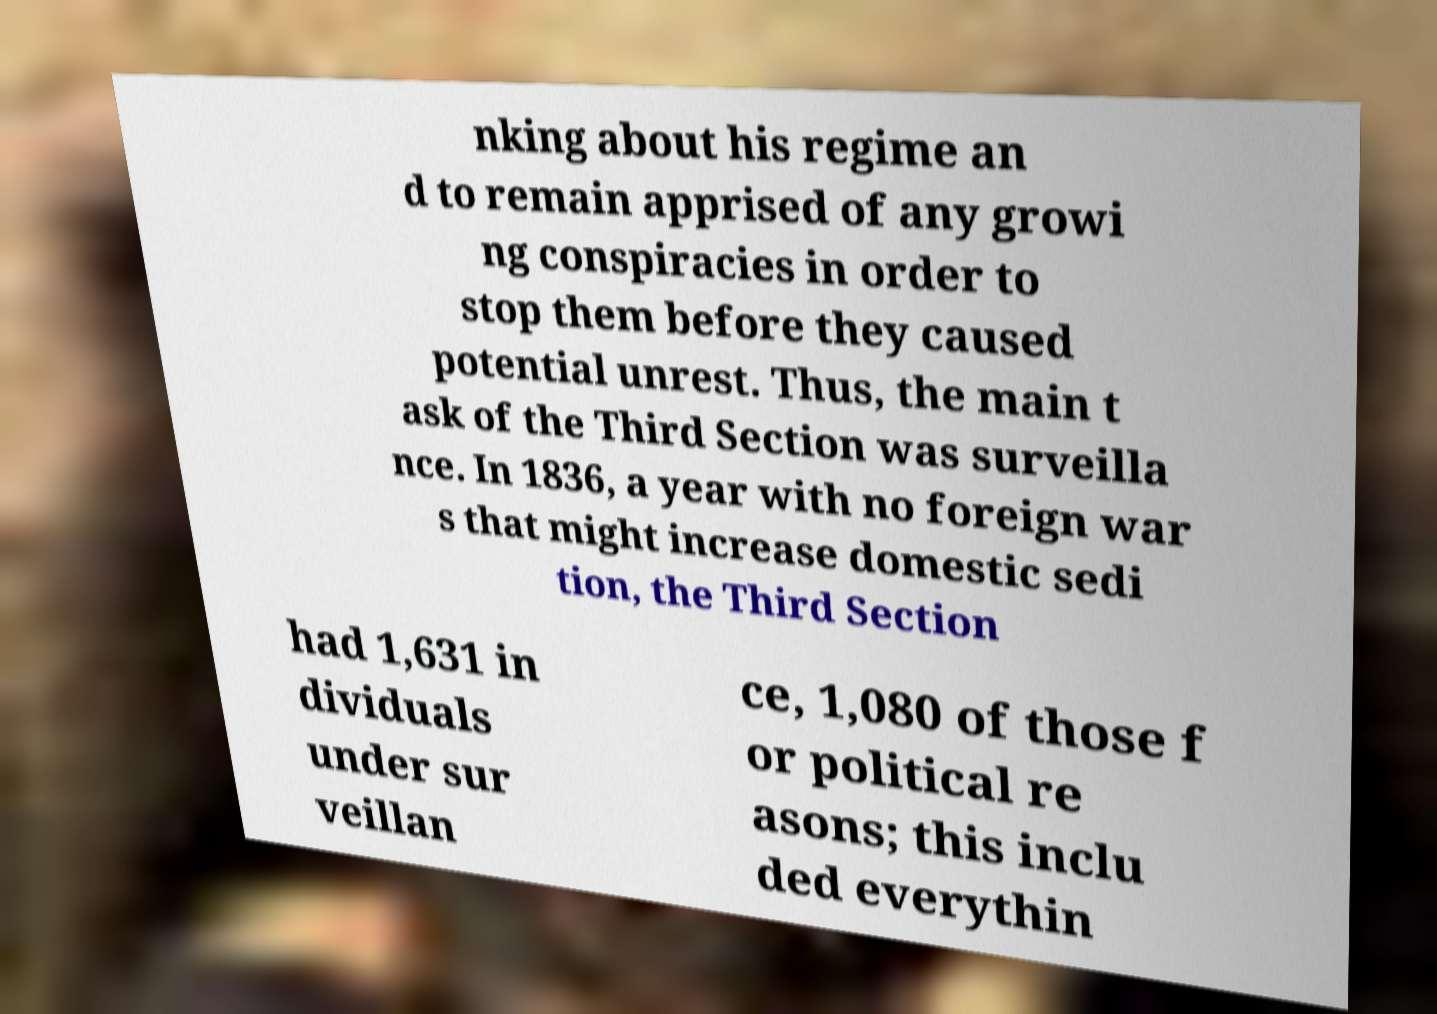What messages or text are displayed in this image? I need them in a readable, typed format. nking about his regime an d to remain apprised of any growi ng conspiracies in order to stop them before they caused potential unrest. Thus, the main t ask of the Third Section was surveilla nce. In 1836, a year with no foreign war s that might increase domestic sedi tion, the Third Section had 1,631 in dividuals under sur veillan ce, 1,080 of those f or political re asons; this inclu ded everythin 